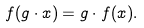<formula> <loc_0><loc_0><loc_500><loc_500>f ( g \cdot x ) = g \cdot f ( x ) .</formula> 